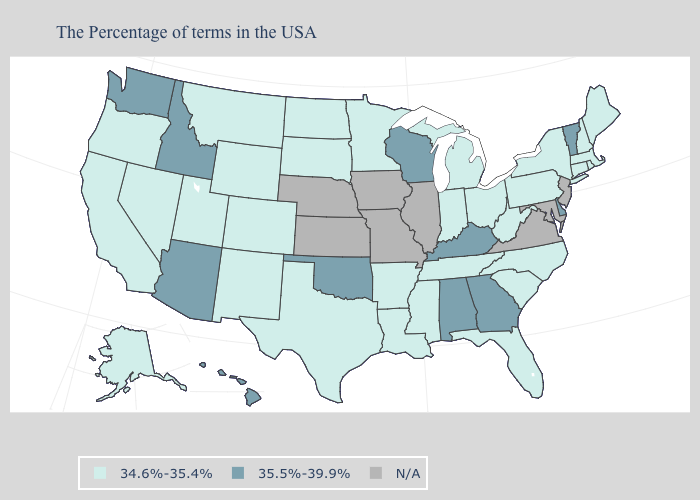Name the states that have a value in the range N/A?
Keep it brief. New Jersey, Maryland, Virginia, Illinois, Missouri, Iowa, Kansas, Nebraska. What is the value of Indiana?
Short answer required. 34.6%-35.4%. What is the value of Arizona?
Keep it brief. 35.5%-39.9%. Among the states that border Iowa , which have the lowest value?
Short answer required. Minnesota, South Dakota. Name the states that have a value in the range N/A?
Be succinct. New Jersey, Maryland, Virginia, Illinois, Missouri, Iowa, Kansas, Nebraska. What is the highest value in the Northeast ?
Keep it brief. 35.5%-39.9%. Name the states that have a value in the range 34.6%-35.4%?
Write a very short answer. Maine, Massachusetts, Rhode Island, New Hampshire, Connecticut, New York, Pennsylvania, North Carolina, South Carolina, West Virginia, Ohio, Florida, Michigan, Indiana, Tennessee, Mississippi, Louisiana, Arkansas, Minnesota, Texas, South Dakota, North Dakota, Wyoming, Colorado, New Mexico, Utah, Montana, Nevada, California, Oregon, Alaska. Does the map have missing data?
Concise answer only. Yes. Name the states that have a value in the range 35.5%-39.9%?
Give a very brief answer. Vermont, Delaware, Georgia, Kentucky, Alabama, Wisconsin, Oklahoma, Arizona, Idaho, Washington, Hawaii. What is the lowest value in states that border Oregon?
Write a very short answer. 34.6%-35.4%. Name the states that have a value in the range 35.5%-39.9%?
Answer briefly. Vermont, Delaware, Georgia, Kentucky, Alabama, Wisconsin, Oklahoma, Arizona, Idaho, Washington, Hawaii. Does Delaware have the highest value in the South?
Be succinct. Yes. Which states have the lowest value in the Northeast?
Be succinct. Maine, Massachusetts, Rhode Island, New Hampshire, Connecticut, New York, Pennsylvania. Does Wisconsin have the highest value in the MidWest?
Short answer required. Yes. 